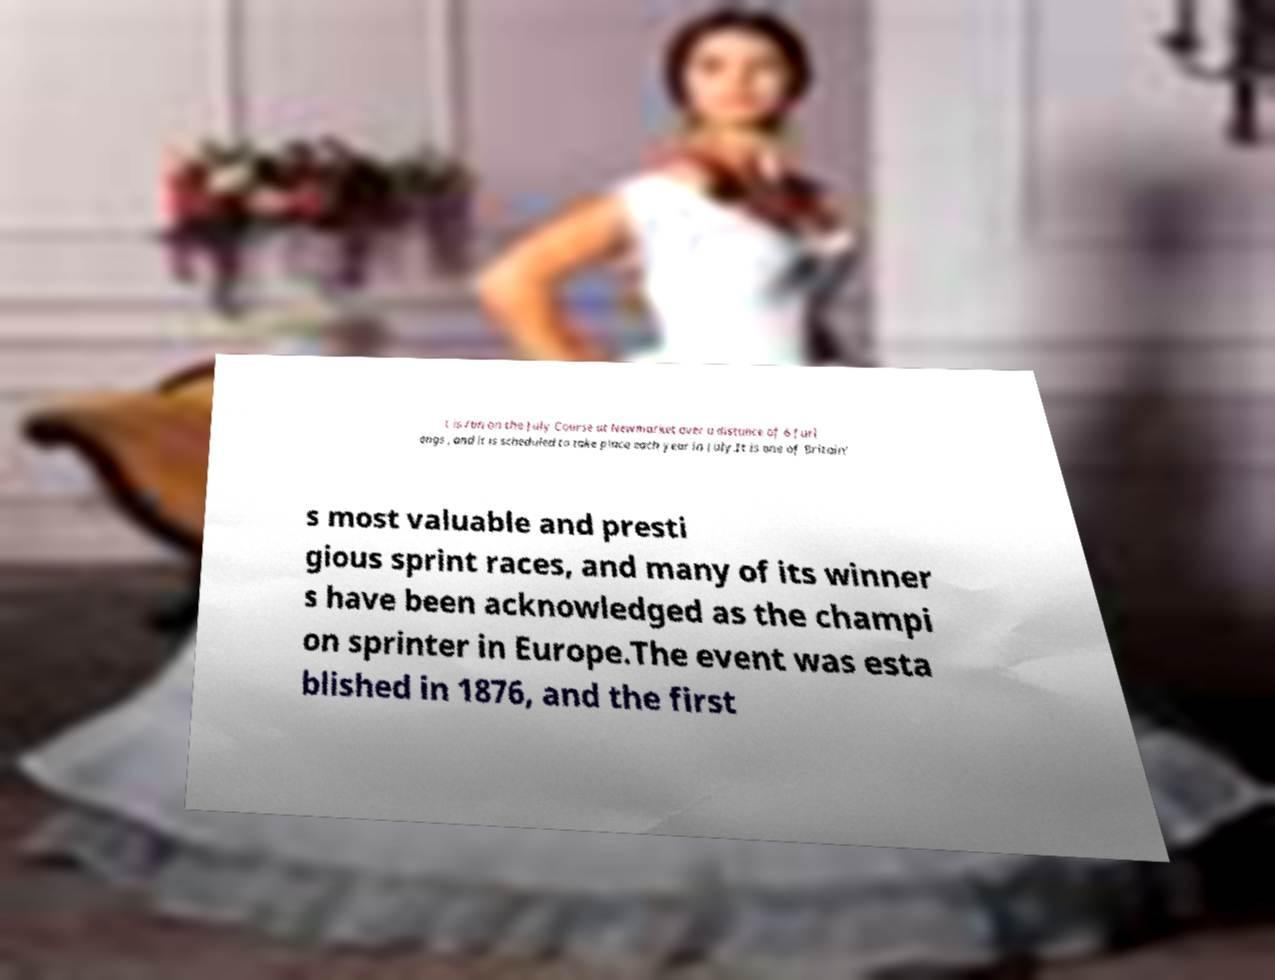Can you accurately transcribe the text from the provided image for me? t is run on the July Course at Newmarket over a distance of 6 furl ongs , and it is scheduled to take place each year in July.It is one of Britain' s most valuable and presti gious sprint races, and many of its winner s have been acknowledged as the champi on sprinter in Europe.The event was esta blished in 1876, and the first 